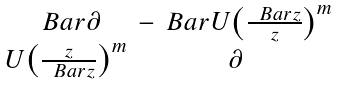<formula> <loc_0><loc_0><loc_500><loc_500>\begin{smallmatrix} \ B a r { \partial } & - \ B a r { U } \left ( \frac { \ B a r { z } } { z } \right ) ^ { m } \\ U \left ( \frac { z } { \ B a r { z } } \right ) ^ { m } & \partial \end{smallmatrix}</formula> 